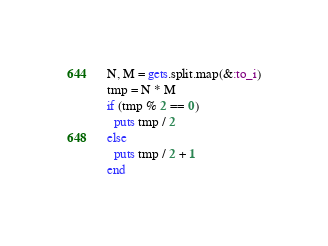<code> <loc_0><loc_0><loc_500><loc_500><_Ruby_>N, M = gets.split.map(&:to_i)
tmp = N * M
if (tmp % 2 == 0)
  puts tmp / 2
else
  puts tmp / 2 + 1
end</code> 